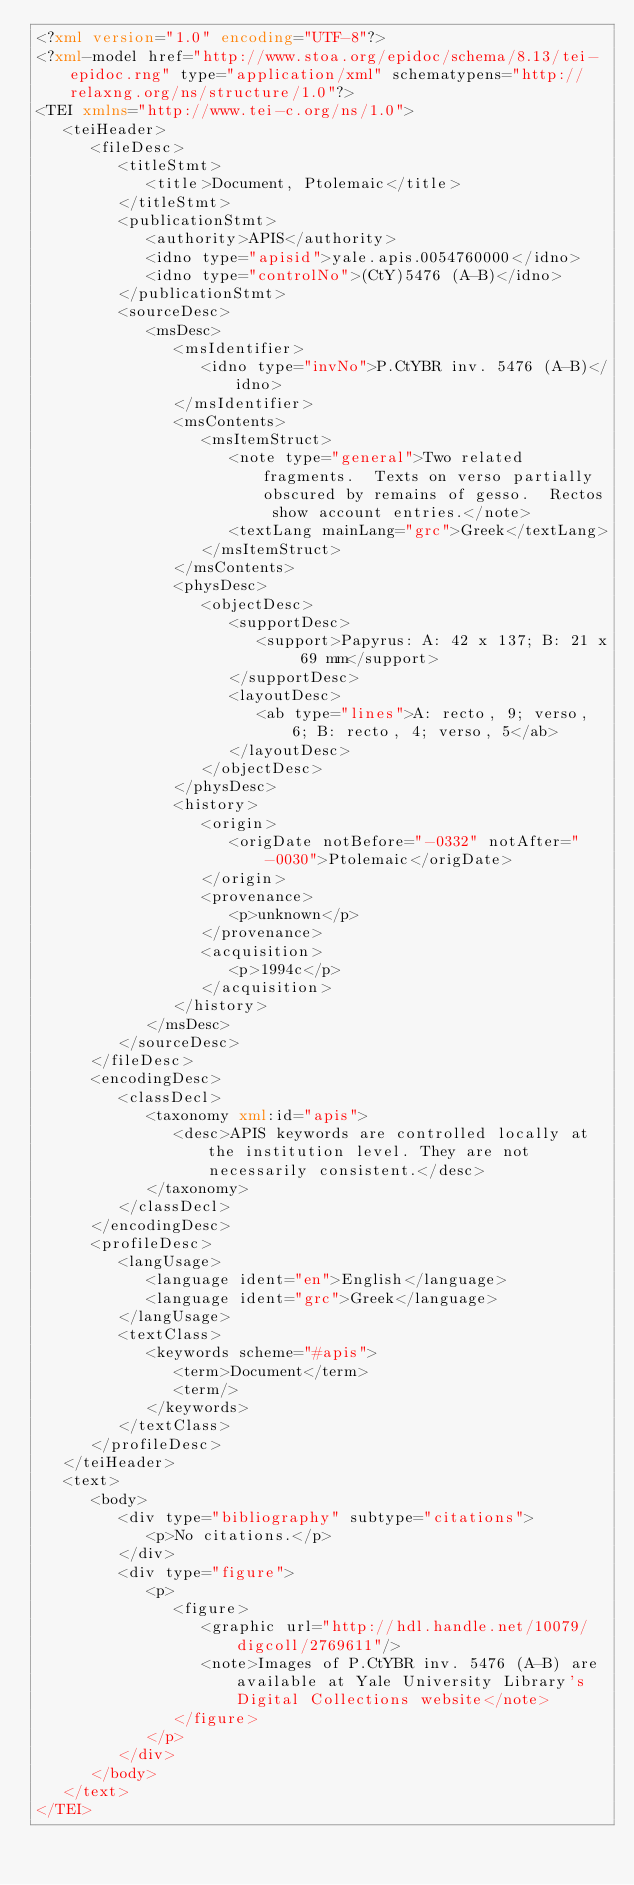<code> <loc_0><loc_0><loc_500><loc_500><_XML_><?xml version="1.0" encoding="UTF-8"?>
<?xml-model href="http://www.stoa.org/epidoc/schema/8.13/tei-epidoc.rng" type="application/xml" schematypens="http://relaxng.org/ns/structure/1.0"?>
<TEI xmlns="http://www.tei-c.org/ns/1.0">
   <teiHeader>
      <fileDesc>
         <titleStmt>
            <title>Document, Ptolemaic</title>
         </titleStmt>
         <publicationStmt>
            <authority>APIS</authority>
            <idno type="apisid">yale.apis.0054760000</idno>
            <idno type="controlNo">(CtY)5476 (A-B)</idno>
         </publicationStmt>
         <sourceDesc>
            <msDesc>
               <msIdentifier>
                  <idno type="invNo">P.CtYBR inv. 5476 (A-B)</idno>
               </msIdentifier>
               <msContents>
                  <msItemStruct>
                     <note type="general">Two related fragments.  Texts on verso partially obscured by remains of gesso.  Rectos show account entries.</note>
                     <textLang mainLang="grc">Greek</textLang>
                  </msItemStruct>
               </msContents>
               <physDesc>
                  <objectDesc>
                     <supportDesc>
                        <support>Papyrus: A: 42 x 137; B: 21 x 69 mm</support>
                     </supportDesc>
                     <layoutDesc>
                        <ab type="lines">A: recto, 9; verso, 6; B: recto, 4; verso, 5</ab>
                     </layoutDesc>
                  </objectDesc>
               </physDesc>
               <history>
                  <origin>
                     <origDate notBefore="-0332" notAfter="-0030">Ptolemaic</origDate>
                  </origin>
                  <provenance>
                     <p>unknown</p>
                  </provenance>
                  <acquisition>
                     <p>1994c</p>
                  </acquisition>
               </history>
            </msDesc>
         </sourceDesc>
      </fileDesc>
      <encodingDesc>
         <classDecl>
            <taxonomy xml:id="apis">
               <desc>APIS keywords are controlled locally at the institution level. They are not necessarily consistent.</desc>
            </taxonomy>
         </classDecl>
      </encodingDesc>
      <profileDesc>
         <langUsage>
            <language ident="en">English</language>
            <language ident="grc">Greek</language>
         </langUsage>
         <textClass>
            <keywords scheme="#apis">
               <term>Document</term>
               <term/>
            </keywords>
         </textClass>
      </profileDesc>
   </teiHeader>
   <text>
      <body>
         <div type="bibliography" subtype="citations">
            <p>No citations.</p>
         </div>
         <div type="figure">
            <p>
               <figure>
                  <graphic url="http://hdl.handle.net/10079/digcoll/2769611"/>
                  <note>Images of P.CtYBR inv. 5476 (A-B) are available at Yale University Library's Digital Collections website</note>
               </figure>
            </p>
         </div>
      </body>
   </text>
</TEI>
</code> 